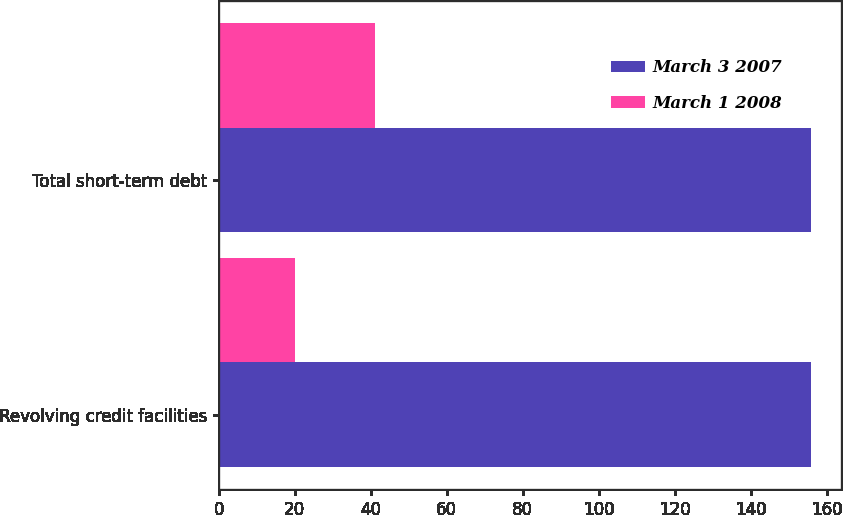Convert chart to OTSL. <chart><loc_0><loc_0><loc_500><loc_500><stacked_bar_chart><ecel><fcel>Revolving credit facilities<fcel>Total short-term debt<nl><fcel>March 3 2007<fcel>156<fcel>156<nl><fcel>March 1 2008<fcel>20<fcel>41<nl></chart> 